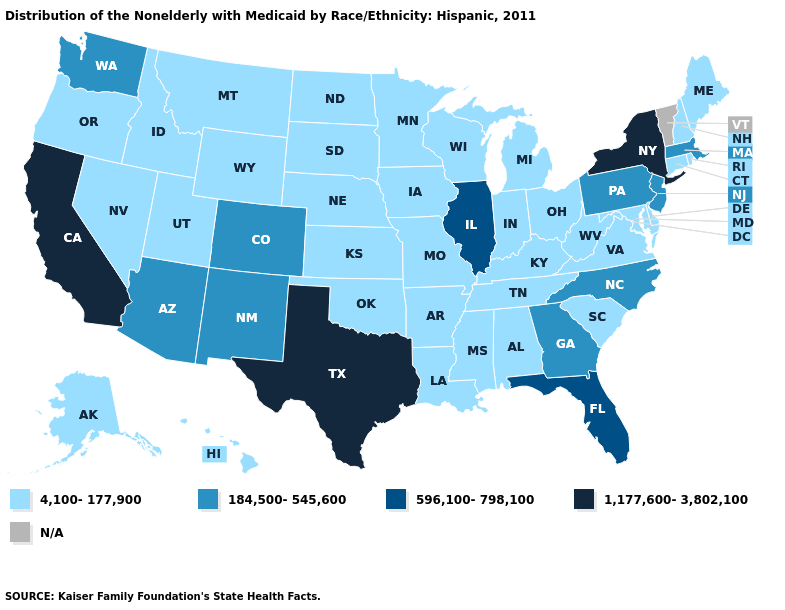Does Washington have the lowest value in the West?
Concise answer only. No. Among the states that border Rhode Island , which have the highest value?
Answer briefly. Massachusetts. Does Nebraska have the lowest value in the MidWest?
Concise answer only. Yes. Is the legend a continuous bar?
Be succinct. No. What is the value of Michigan?
Answer briefly. 4,100-177,900. What is the value of Maine?
Keep it brief. 4,100-177,900. What is the value of North Dakota?
Answer briefly. 4,100-177,900. What is the highest value in the MidWest ?
Write a very short answer. 596,100-798,100. What is the highest value in the MidWest ?
Short answer required. 596,100-798,100. What is the lowest value in the USA?
Give a very brief answer. 4,100-177,900. Among the states that border Tennessee , does Arkansas have the lowest value?
Write a very short answer. Yes. Does Texas have the highest value in the South?
Answer briefly. Yes. What is the value of Alaska?
Concise answer only. 4,100-177,900. 